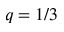Convert formula to latex. <formula><loc_0><loc_0><loc_500><loc_500>q = 1 / 3</formula> 